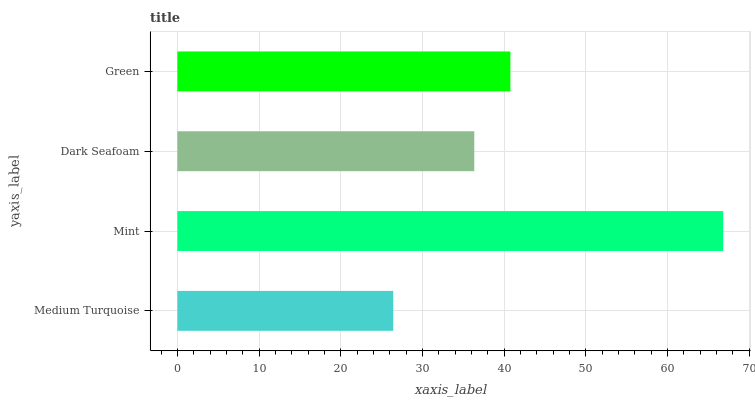Is Medium Turquoise the minimum?
Answer yes or no. Yes. Is Mint the maximum?
Answer yes or no. Yes. Is Dark Seafoam the minimum?
Answer yes or no. No. Is Dark Seafoam the maximum?
Answer yes or no. No. Is Mint greater than Dark Seafoam?
Answer yes or no. Yes. Is Dark Seafoam less than Mint?
Answer yes or no. Yes. Is Dark Seafoam greater than Mint?
Answer yes or no. No. Is Mint less than Dark Seafoam?
Answer yes or no. No. Is Green the high median?
Answer yes or no. Yes. Is Dark Seafoam the low median?
Answer yes or no. Yes. Is Medium Turquoise the high median?
Answer yes or no. No. Is Green the low median?
Answer yes or no. No. 